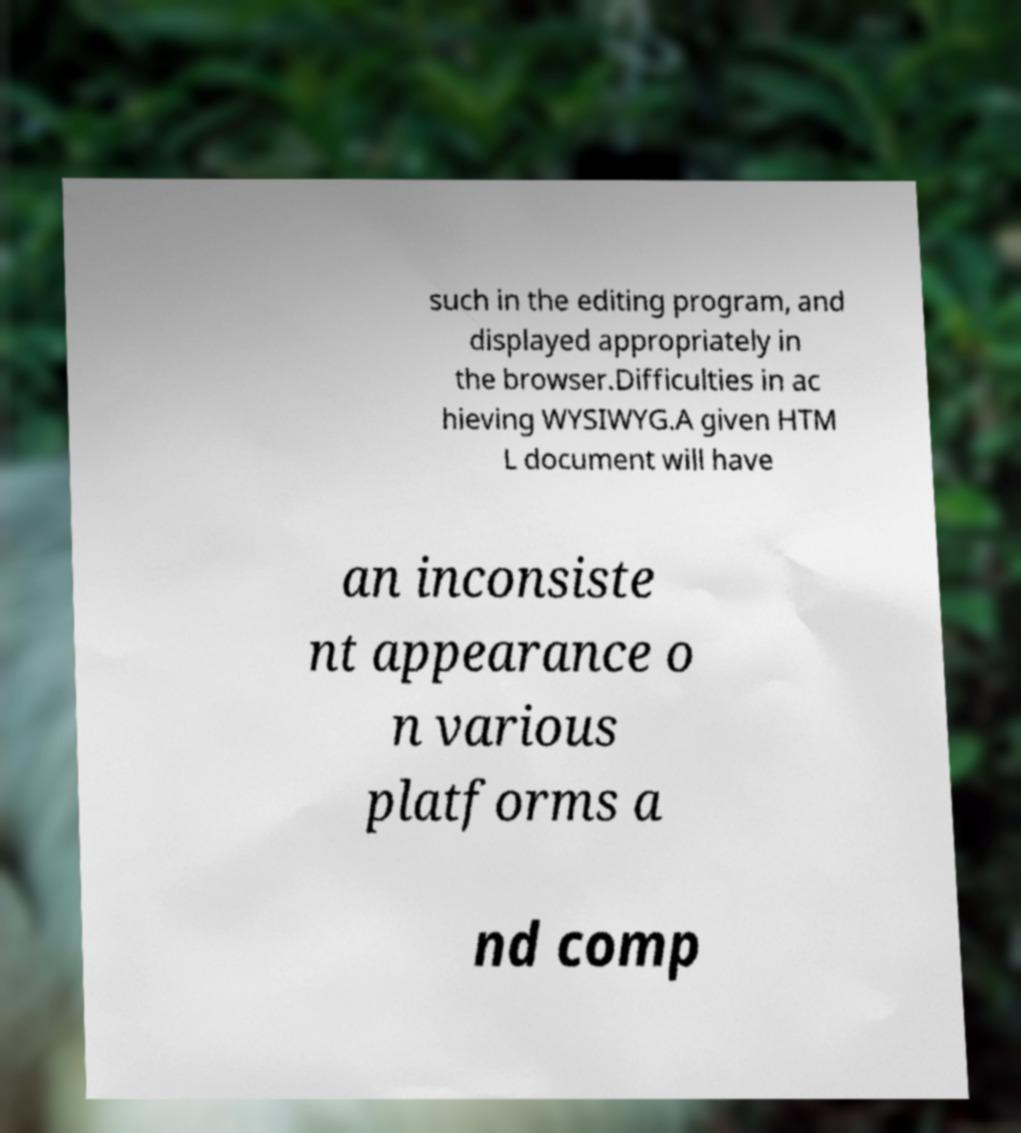Please identify and transcribe the text found in this image. such in the editing program, and displayed appropriately in the browser.Difficulties in ac hieving WYSIWYG.A given HTM L document will have an inconsiste nt appearance o n various platforms a nd comp 